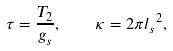<formula> <loc_0><loc_0><loc_500><loc_500>\tau = \frac { T _ { 2 } } { g _ { s } } , \quad \kappa = 2 \pi { l _ { s } } ^ { 2 } ,</formula> 